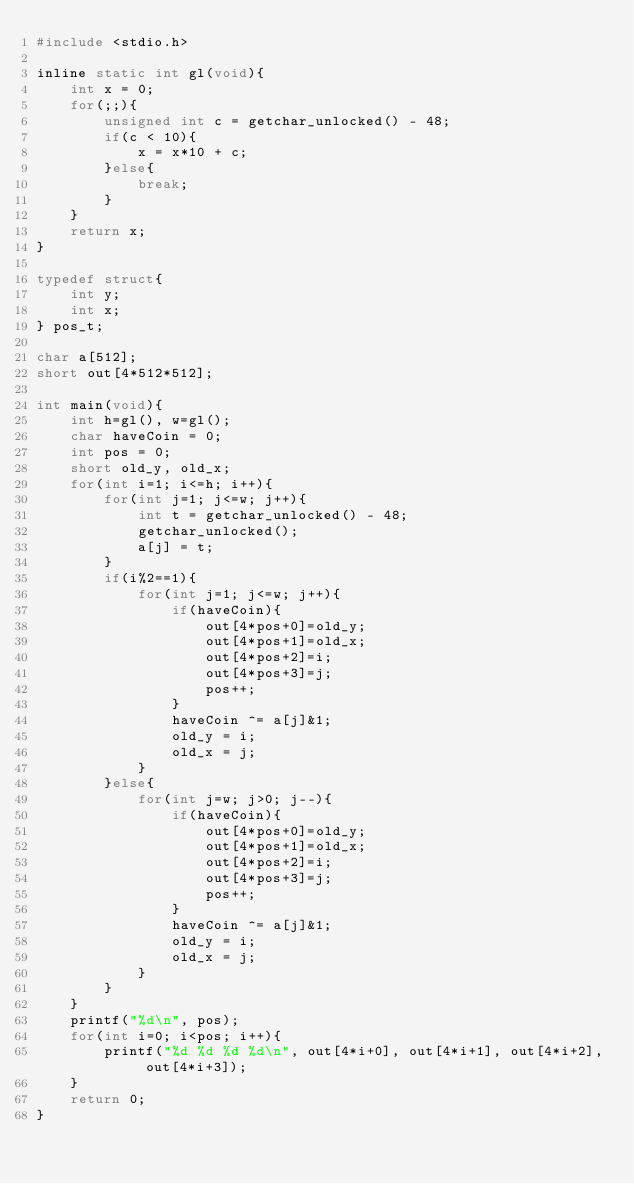<code> <loc_0><loc_0><loc_500><loc_500><_C_>#include <stdio.h>

inline static int gl(void){
    int x = 0;
    for(;;){
        unsigned int c = getchar_unlocked() - 48;
        if(c < 10){
            x = x*10 + c;
        }else{
            break;
        }
    }
    return x;
}

typedef struct{
    int y;
    int x;
} pos_t;

char a[512];
short out[4*512*512];

int main(void){
    int h=gl(), w=gl();
    char haveCoin = 0;
    int pos = 0;
    short old_y, old_x;
    for(int i=1; i<=h; i++){
        for(int j=1; j<=w; j++){
            int t = getchar_unlocked() - 48;
            getchar_unlocked();
            a[j] = t;
        }
        if(i%2==1){
            for(int j=1; j<=w; j++){
                if(haveCoin){
                    out[4*pos+0]=old_y;
                    out[4*pos+1]=old_x;
                    out[4*pos+2]=i;
                    out[4*pos+3]=j;
                    pos++;
                }
                haveCoin ^= a[j]&1;
                old_y = i;
                old_x = j;
            }
        }else{
            for(int j=w; j>0; j--){
                if(haveCoin){
                    out[4*pos+0]=old_y;
                    out[4*pos+1]=old_x;
                    out[4*pos+2]=i;
                    out[4*pos+3]=j;
                    pos++;
                }
                haveCoin ^= a[j]&1;
                old_y = i;
                old_x = j;
            }
        }
    }
    printf("%d\n", pos);
    for(int i=0; i<pos; i++){
        printf("%d %d %d %d\n", out[4*i+0], out[4*i+1], out[4*i+2], out[4*i+3]);
    }
    return 0;
}
</code> 